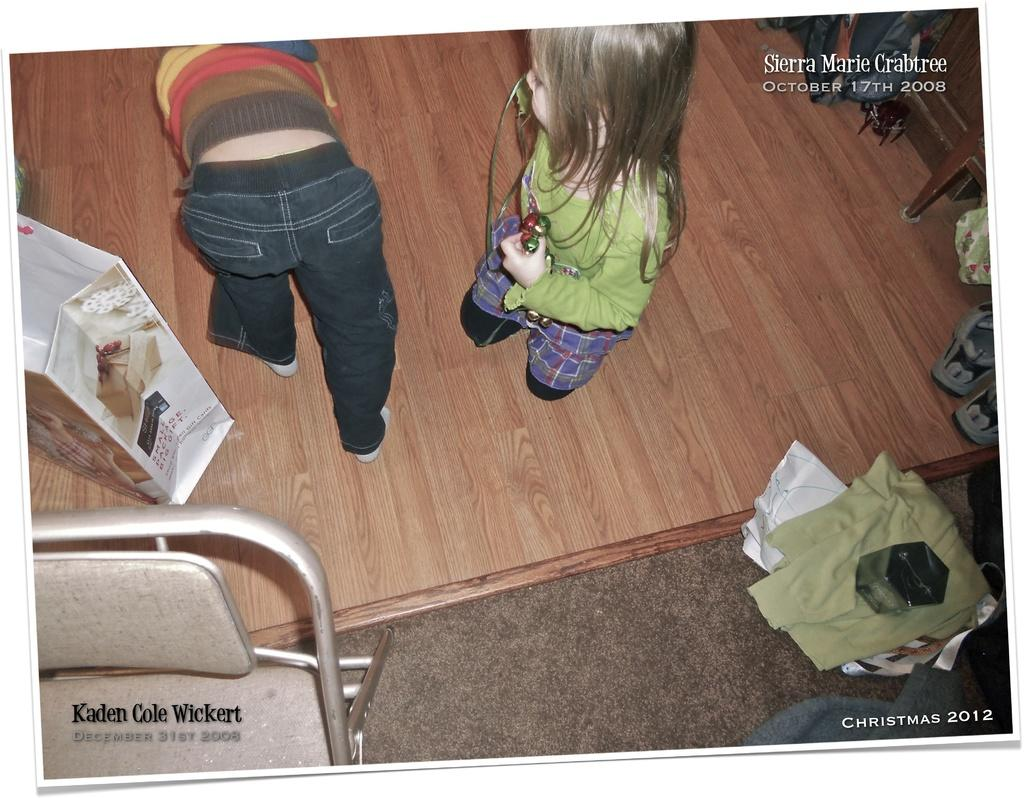What are the kids doing in the image? The kids are on the floor in the image. What is located beside the kids? There is a bag beside the kids. Can you describe any furniture in the image? There is a chair in the image. What type of footwear can be seen in the image? There are shoes in the image. What other unspecified items are present in the image? There are other unspecified things in the image. What is the value of the lake in the image? There is no lake present in the image, so it is not possible to determine its value. 